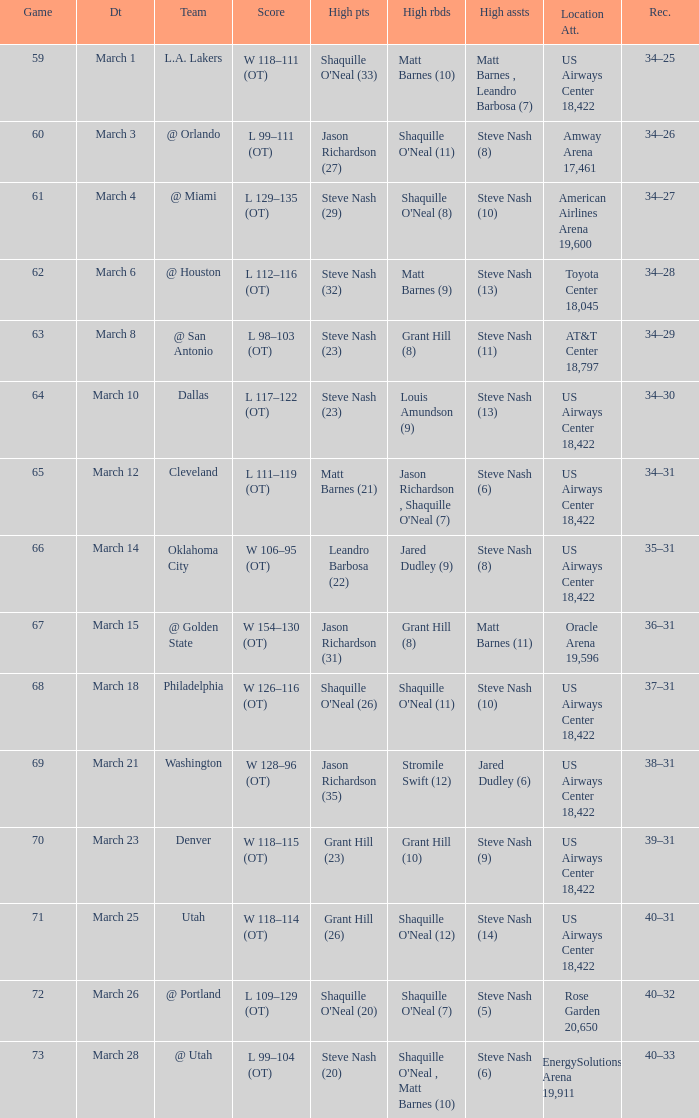After the March 15 game, what was the team's record? 36–31. 